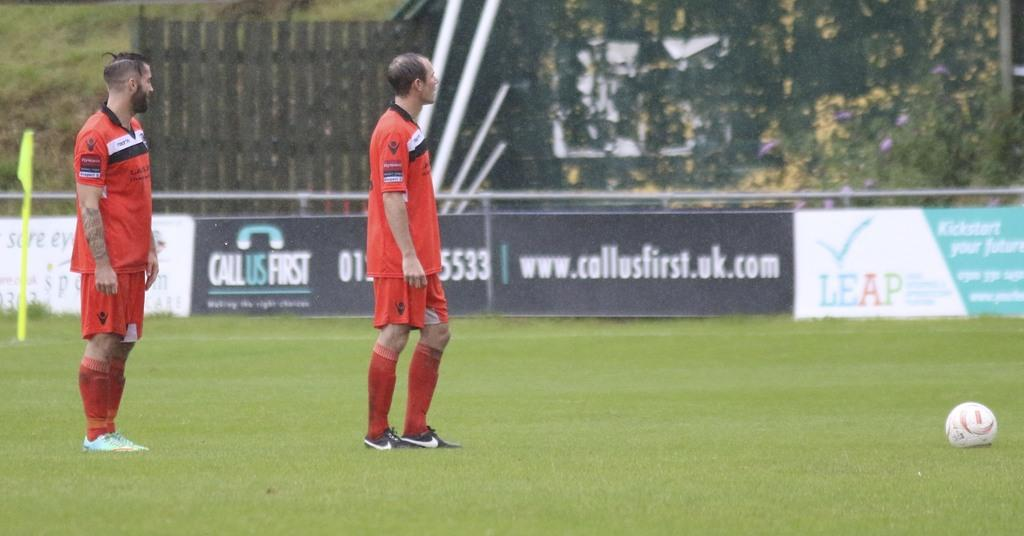<image>
Present a compact description of the photo's key features. A banner for Call Us First is along the fence line. 